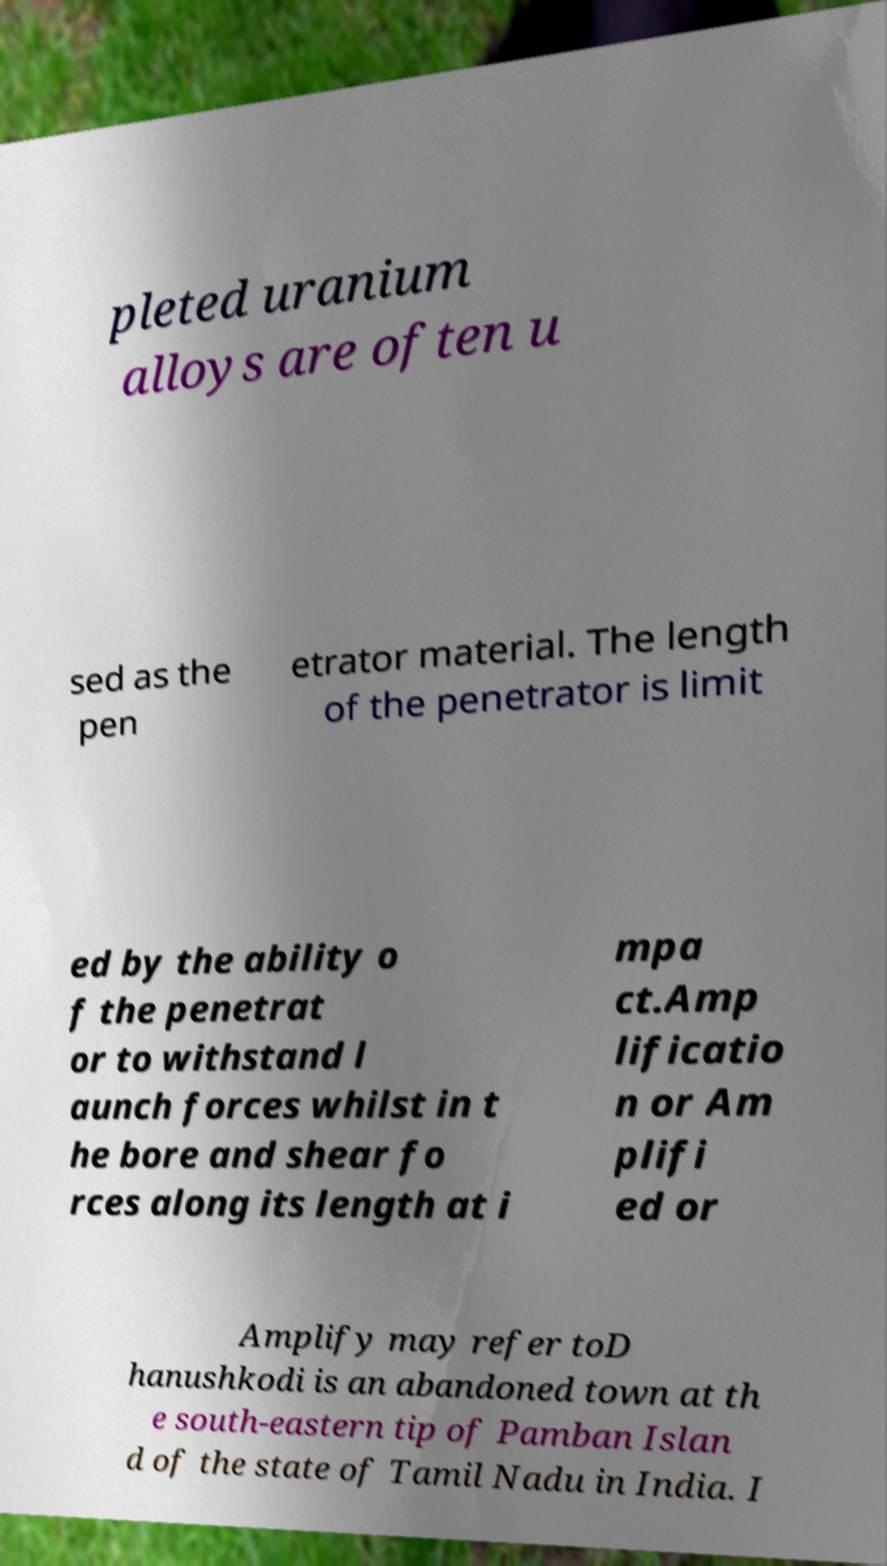Can you accurately transcribe the text from the provided image for me? pleted uranium alloys are often u sed as the pen etrator material. The length of the penetrator is limit ed by the ability o f the penetrat or to withstand l aunch forces whilst in t he bore and shear fo rces along its length at i mpa ct.Amp lificatio n or Am plifi ed or Amplify may refer toD hanushkodi is an abandoned town at th e south-eastern tip of Pamban Islan d of the state of Tamil Nadu in India. I 